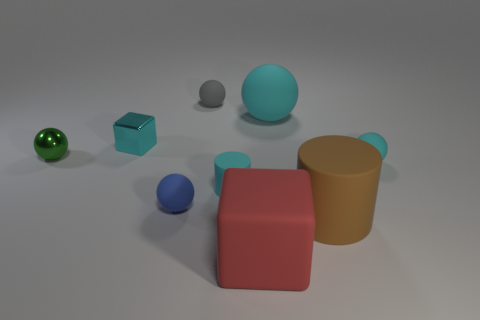Add 1 large red objects. How many objects exist? 10 Subtract all big rubber balls. How many balls are left? 4 Subtract 0 yellow spheres. How many objects are left? 9 Subtract all blocks. How many objects are left? 7 Subtract 1 blocks. How many blocks are left? 1 Subtract all blue spheres. Subtract all purple cylinders. How many spheres are left? 4 Subtract all cyan cylinders. How many gray balls are left? 1 Subtract all small cyan matte balls. Subtract all big matte cubes. How many objects are left? 7 Add 1 tiny green shiny objects. How many tiny green shiny objects are left? 2 Add 1 large objects. How many large objects exist? 4 